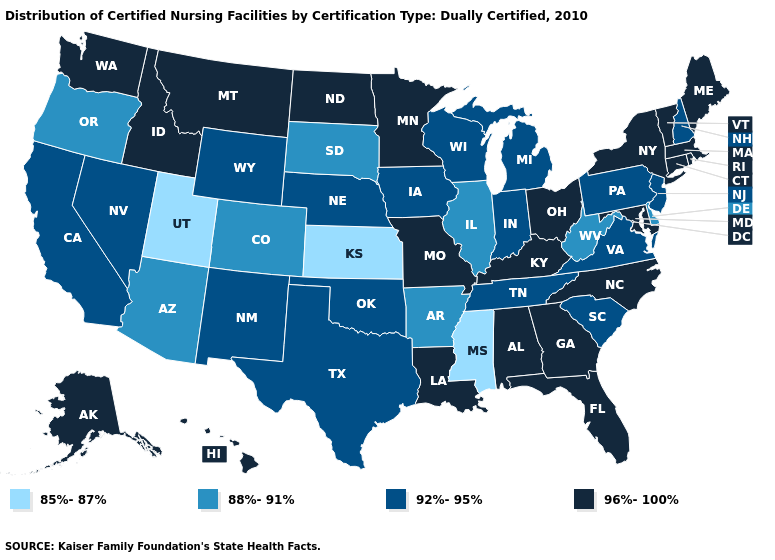What is the lowest value in states that border Idaho?
Be succinct. 85%-87%. What is the lowest value in states that border New Mexico?
Answer briefly. 85%-87%. Does South Dakota have the lowest value in the MidWest?
Give a very brief answer. No. What is the highest value in the South ?
Write a very short answer. 96%-100%. Name the states that have a value in the range 85%-87%?
Be succinct. Kansas, Mississippi, Utah. Does the map have missing data?
Concise answer only. No. Name the states that have a value in the range 85%-87%?
Short answer required. Kansas, Mississippi, Utah. Does Nevada have a lower value than Delaware?
Keep it brief. No. What is the value of South Carolina?
Be succinct. 92%-95%. What is the value of Ohio?
Be succinct. 96%-100%. Name the states that have a value in the range 92%-95%?
Write a very short answer. California, Indiana, Iowa, Michigan, Nebraska, Nevada, New Hampshire, New Jersey, New Mexico, Oklahoma, Pennsylvania, South Carolina, Tennessee, Texas, Virginia, Wisconsin, Wyoming. What is the highest value in states that border Colorado?
Keep it brief. 92%-95%. Does Illinois have a higher value than North Carolina?
Write a very short answer. No. Does Mississippi have the lowest value in the South?
Short answer required. Yes. How many symbols are there in the legend?
Give a very brief answer. 4. 